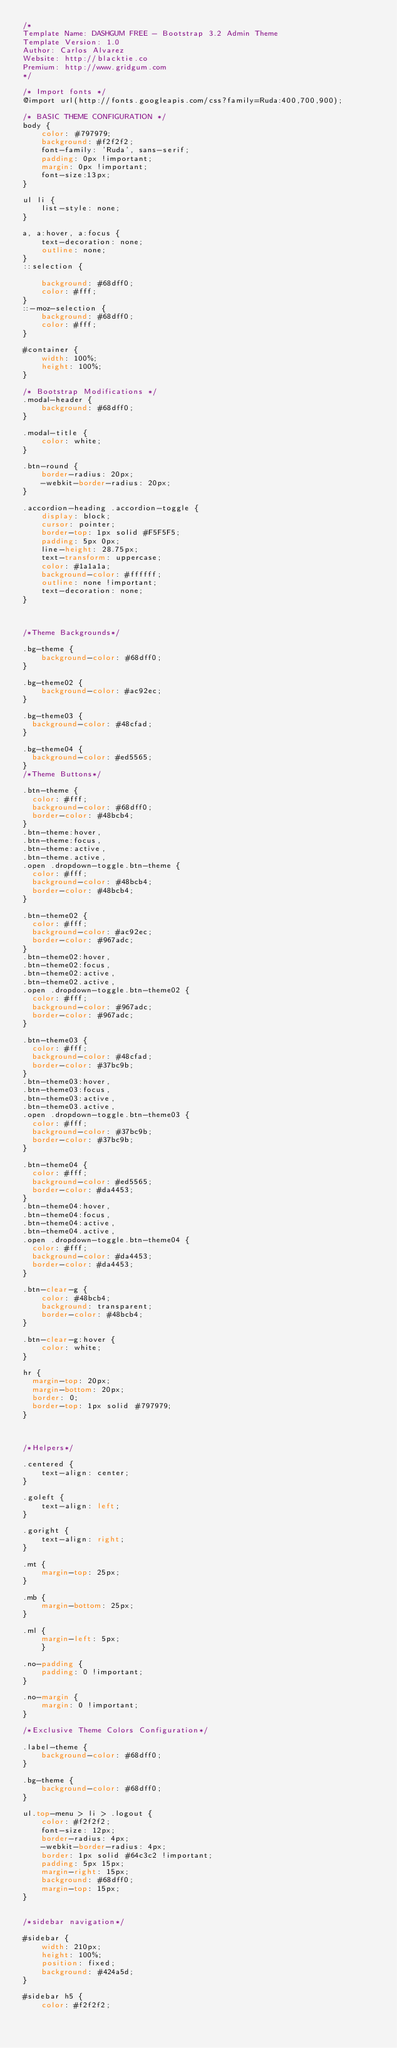<code> <loc_0><loc_0><loc_500><loc_500><_CSS_>/*
Template Name: DASHGUM FREE - Bootstrap 3.2 Admin Theme
Template Version: 1.0
Author: Carlos Alvarez
Website: http://blacktie.co
Premium: http://www.gridgum.com
*/

/* Import fonts */
@import url(http://fonts.googleapis.com/css?family=Ruda:400,700,900);

/* BASIC THEME CONFIGURATION */
body {
    color: #797979;
	background: #f2f2f2;
    font-family: 'Ruda', sans-serif;
    padding: 0px !important;
    margin: 0px !important;
    font-size:13px;
}

ul li {
    list-style: none;
}

a, a:hover, a:focus {
    text-decoration: none;
    outline: none;
}
::selection {

    background: #68dff0;
    color: #fff;
}
::-moz-selection {
    background: #68dff0;
    color: #fff;
}

#container {
    width: 100%;
    height: 100%;
}

/* Bootstrap Modifications */
.modal-header {
	background: #68dff0;
}

.modal-title {
	color: white;
}

.btn-round {
	border-radius: 20px;
	-webkit-border-radius: 20px;
}

.accordion-heading .accordion-toggle {
	display: block;
	cursor: pointer;
	border-top: 1px solid #F5F5F5;
	padding: 5px 0px;
	line-height: 28.75px;
	text-transform: uppercase;
	color: #1a1a1a;
	background-color: #ffffff;
	outline: none !important;
	text-decoration: none;
}	



/*Theme Backgrounds*/

.bg-theme {
	background-color: #68dff0;
}

.bg-theme02 {
	background-color: #ac92ec;
}

.bg-theme03 {
  background-color: #48cfad;
}

.bg-theme04 {
  background-color: #ed5565;
}
/*Theme Buttons*/

.btn-theme {
  color: #fff;
  background-color: #68dff0;
  border-color: #48bcb4;
}
.btn-theme:hover,
.btn-theme:focus,
.btn-theme:active,
.btn-theme.active,
.open .dropdown-toggle.btn-theme {
  color: #fff;
  background-color: #48bcb4;
  border-color: #48bcb4;
}

.btn-theme02 {
  color: #fff;
  background-color: #ac92ec;
  border-color: #967adc;
}
.btn-theme02:hover,
.btn-theme02:focus,
.btn-theme02:active,
.btn-theme02.active,
.open .dropdown-toggle.btn-theme02 {
  color: #fff;
  background-color: #967adc;
  border-color: #967adc;
}

.btn-theme03 {
  color: #fff;
  background-color: #48cfad;
  border-color: #37bc9b;
}
.btn-theme03:hover,
.btn-theme03:focus,
.btn-theme03:active,
.btn-theme03.active,
.open .dropdown-toggle.btn-theme03 {
  color: #fff;
  background-color: #37bc9b;
  border-color: #37bc9b;
}

.btn-theme04 {
  color: #fff;
  background-color: #ed5565;
  border-color: #da4453;
}
.btn-theme04:hover,
.btn-theme04:focus,
.btn-theme04:active,
.btn-theme04.active,
.open .dropdown-toggle.btn-theme04 {
  color: #fff;
  background-color: #da4453;
  border-color: #da4453;
}

.btn-clear-g {
	color: #48bcb4;
	background: transparent;
	border-color: #48bcb4;
}

.btn-clear-g:hover {
	color: white;
}

hr {
  margin-top: 20px;
  margin-bottom: 20px;
  border: 0;
  border-top: 1px solid #797979;
}



/*Helpers*/

.centered {
	text-align: center;
}

.goleft {
	text-align: left;
}

.goright {
	text-align: right;
}

.mt {
	margin-top: 25px;
}

.mb {
	margin-bottom: 25px;
}

.ml {
	margin-left: 5px;
	}

.no-padding {
	padding: 0 !important;
}

.no-margin {
	margin: 0 !important;
}

/*Exclusive Theme Colors Configuration*/

.label-theme {
	background-color: #68dff0;
}

.bg-theme {
	background-color: #68dff0;
}

ul.top-menu > li > .logout {
	color: #f2f2f2;
	font-size: 12px;
	border-radius: 4px;
	-webkit-border-radius: 4px;
	border: 1px solid #64c3c2 !important;
	padding: 5px 15px;
	margin-right: 15px;
	background: #68dff0;
	margin-top: 15px;
}


/*sidebar navigation*/

#sidebar {
    width: 210px;
    height: 100%;
    position: fixed;
    background: #424a5d;
}

#sidebar h5 {
	color: #f2f2f2;</code> 